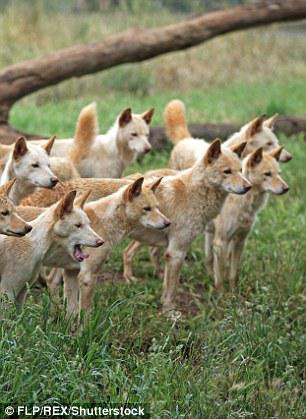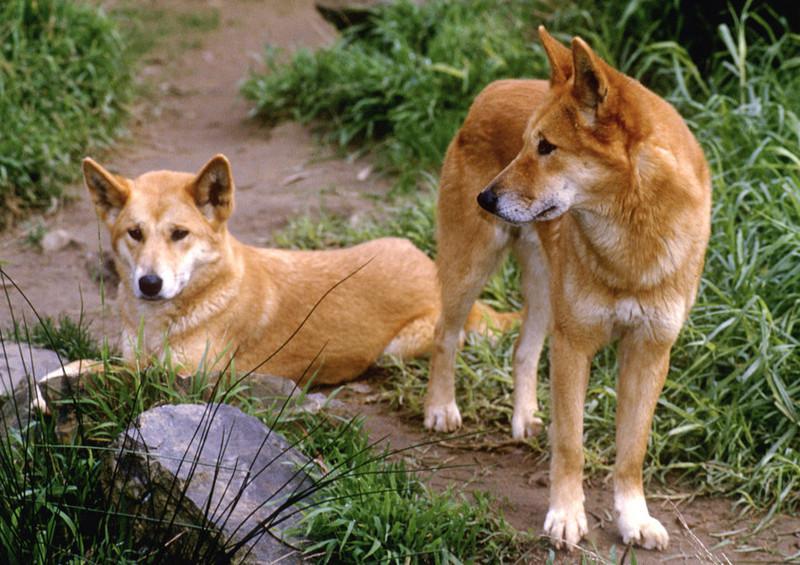The first image is the image on the left, the second image is the image on the right. Given the left and right images, does the statement "The right image includes more than twice the number of dogs as the left image." hold true? Answer yes or no. No. The first image is the image on the left, the second image is the image on the right. For the images shown, is this caption "Several animals are standing in the grass in the image on the left." true? Answer yes or no. Yes. 